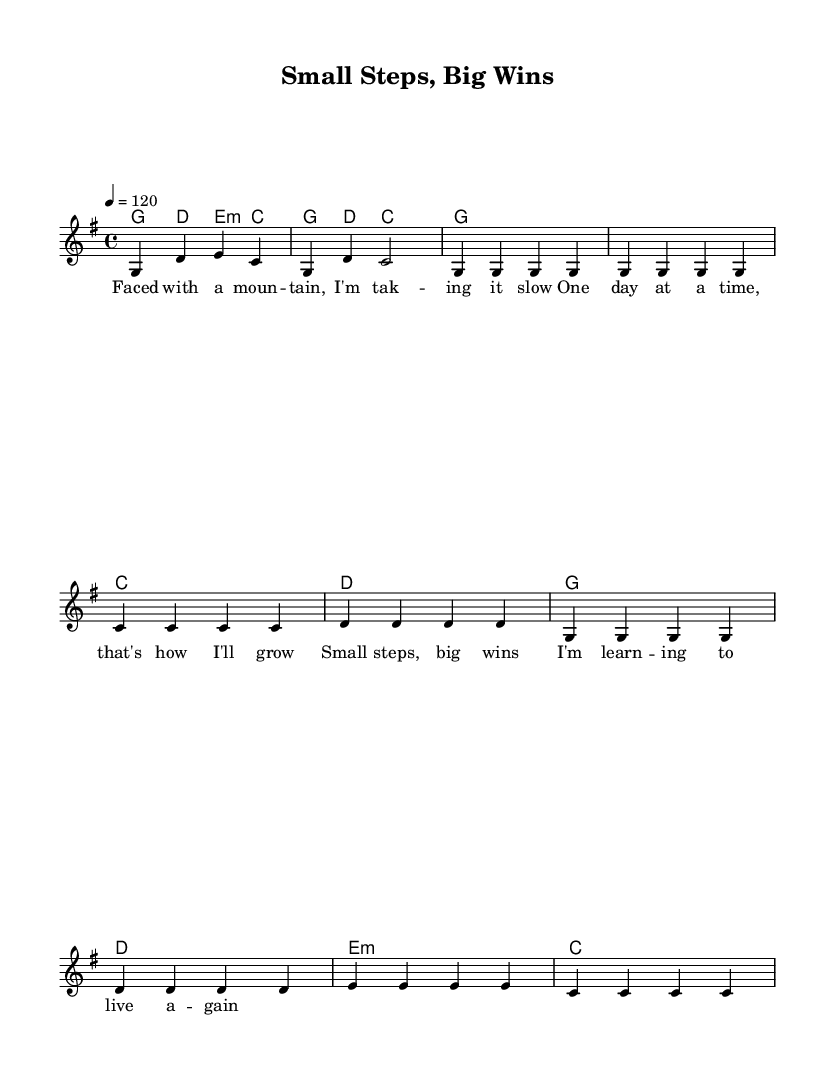What is the key signature of this music? The key signature is G major, which has one sharp (F#). This can be deduced from the initial part of the score where the key signature is indicated.
Answer: G major What is the time signature of this music? The time signature is 4/4, which means there are four beats in each measure, and the quarter note gets the beat. This is evident from the time signature indicated at the beginning of the sheet music.
Answer: 4/4 What is the tempo marking of this piece? The tempo marking is 120 beats per minute, which is indicated in the score. This tells the performer how fast to play the piece.
Answer: 120 How many measures are in the verse section? The verse section, as presented in the excerpt, consists of 8 measures. This can be counted by looking at the bar lines that separate the measures.
Answer: 8 In the chorus, what is the first chord played? The first chord in the chorus is G major, which is the chord indicated at the beginning of the chorus section in the sheet music.
Answer: G What lyrical theme is presented in the verse? The lyrical theme in the verse focuses on taking health journeys slowly and appreciating small progress. It highlights the idea of gradual growth.
Answer: Gradual growth How many lines of lyrics are present for the chorus? There are four lines of lyrics present for the chorus. This can be determined by counting the segments of lyrics that are aligned with the corresponding music notations of the chorus.
Answer: 4 